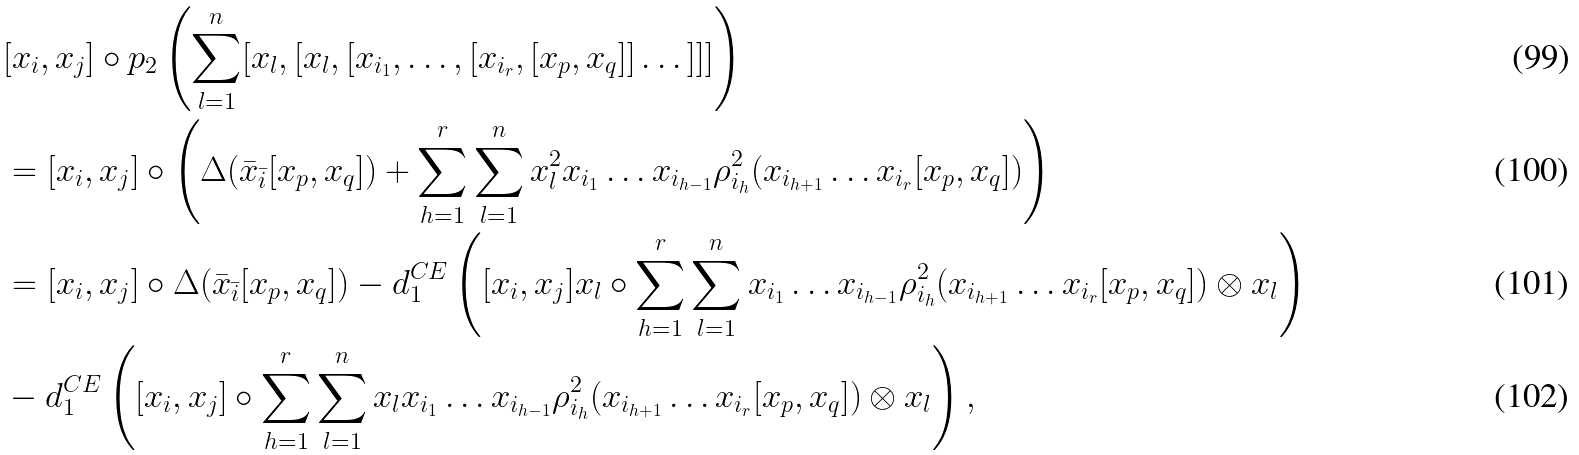Convert formula to latex. <formula><loc_0><loc_0><loc_500><loc_500>& [ x _ { i } , x _ { j } ] \circ p _ { 2 } \left ( \sum _ { l = 1 } ^ { n } [ x _ { l } , [ x _ { l } , [ x _ { i _ { 1 } } , \dots , [ x _ { i _ { r } } , [ x _ { p } , x _ { q } ] ] \dots ] ] ] \right ) \\ & = [ x _ { i } , x _ { j } ] \circ \left ( \Delta ( \bar { x } _ { \bar { i } } [ x _ { p } , x _ { q } ] ) + \sum _ { h = 1 } ^ { r } \sum _ { l = 1 } ^ { n } x _ { l } ^ { 2 } x _ { i _ { 1 } } \dots x _ { i _ { h - 1 } } \rho _ { i _ { h } } ^ { 2 } ( x _ { i _ { h + 1 } } \dots x _ { i _ { r } } [ x _ { p } , x _ { q } ] ) \right ) \\ & = [ x _ { i } , x _ { j } ] \circ \Delta ( \bar { x } _ { \bar { i } } [ x _ { p } , x _ { q } ] ) - d _ { 1 } ^ { C E } \left ( [ x _ { i } , x _ { j } ] x _ { l } \circ \sum _ { h = 1 } ^ { r } \sum _ { l = 1 } ^ { n } x _ { i _ { 1 } } \dots x _ { i _ { h - 1 } } \rho _ { i _ { h } } ^ { 2 } ( x _ { i _ { h + 1 } } \dots x _ { i _ { r } } [ x _ { p } , x _ { q } ] ) \otimes x _ { l } \right ) \\ & - d _ { 1 } ^ { C E } \left ( [ x _ { i } , x _ { j } ] \circ \sum _ { h = 1 } ^ { r } \sum _ { l = 1 } ^ { n } x _ { l } x _ { i _ { 1 } } \dots x _ { i _ { h - 1 } } \rho _ { i _ { h } } ^ { 2 } ( x _ { i _ { h + 1 } } \dots x _ { i _ { r } } [ x _ { p } , x _ { q } ] ) \otimes x _ { l } \right ) ,</formula> 